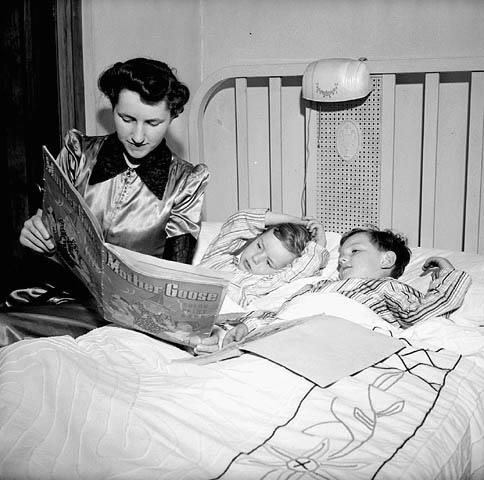What type of magazine are they reading?
Quick response, please. Mother goose. Are kids two boys?
Short answer required. Yes. Is the woman feeling cold?
Write a very short answer. No. Is this woman laying down?
Give a very brief answer. No. What book is the woman reading to the children?
Write a very short answer. Mother goose. What is she sitting on?
Keep it brief. Bed. Is the woman reading?
Short answer required. Yes. What material is the bed frame made of?
Be succinct. Metal. 